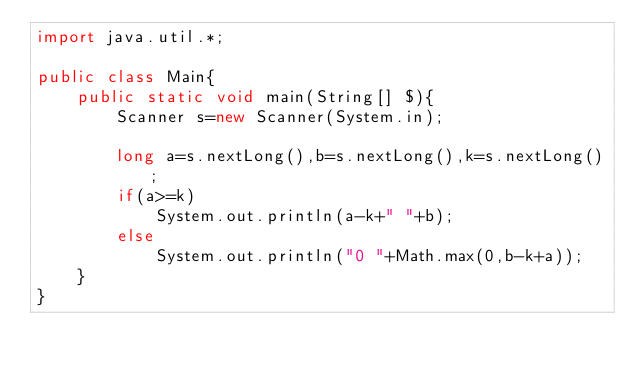Convert code to text. <code><loc_0><loc_0><loc_500><loc_500><_Java_>import java.util.*;

public class Main{
	public static void main(String[] $){
		Scanner s=new Scanner(System.in);

		long a=s.nextLong(),b=s.nextLong(),k=s.nextLong();
		if(a>=k)
			System.out.println(a-k+" "+b);
		else
			System.out.println("0 "+Math.max(0,b-k+a));
	}
}
</code> 